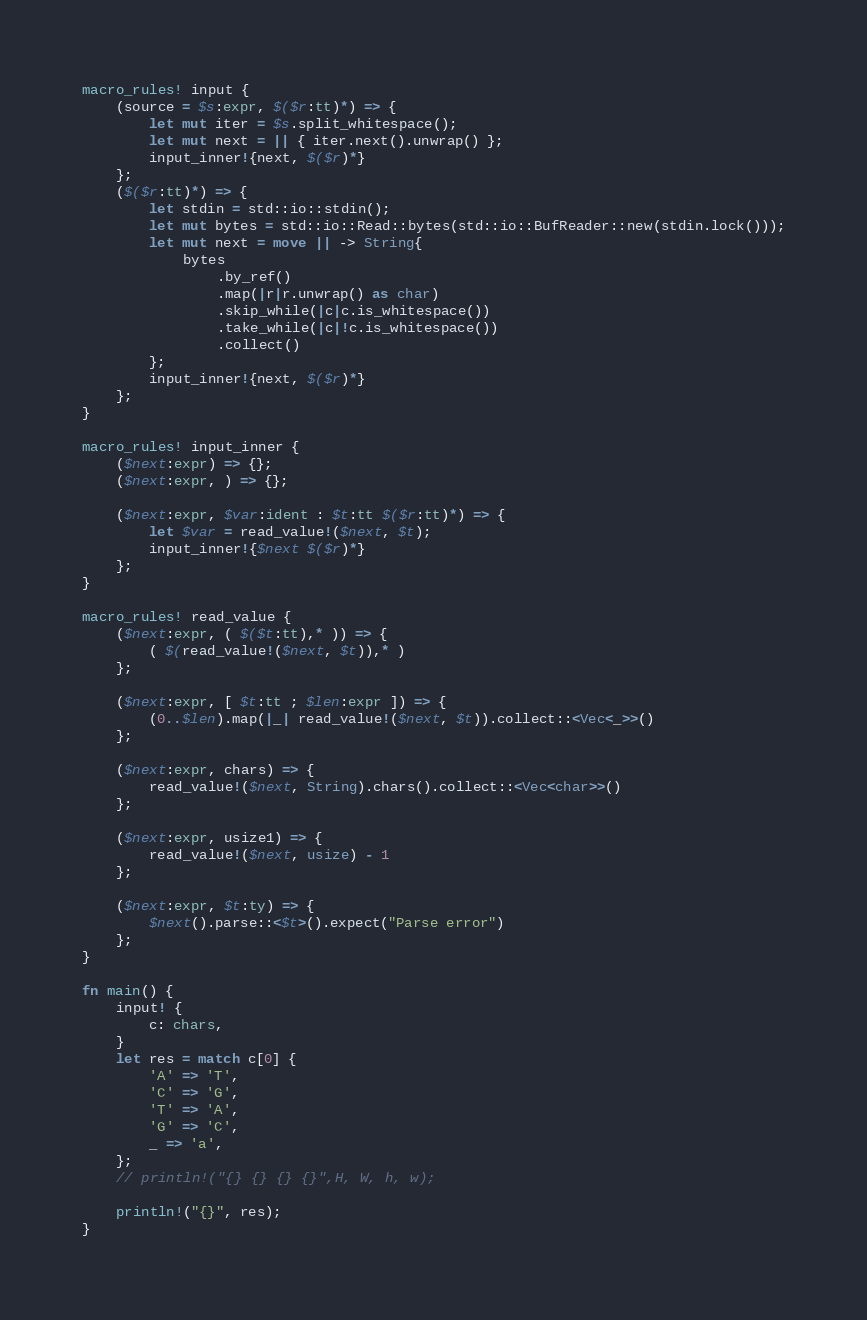Convert code to text. <code><loc_0><loc_0><loc_500><loc_500><_Rust_>macro_rules! input {
    (source = $s:expr, $($r:tt)*) => {
        let mut iter = $s.split_whitespace();
        let mut next = || { iter.next().unwrap() };
        input_inner!{next, $($r)*}
    };
    ($($r:tt)*) => {
        let stdin = std::io::stdin();
        let mut bytes = std::io::Read::bytes(std::io::BufReader::new(stdin.lock()));
        let mut next = move || -> String{
            bytes
                .by_ref()
                .map(|r|r.unwrap() as char)
                .skip_while(|c|c.is_whitespace())
                .take_while(|c|!c.is_whitespace())
                .collect()
        };
        input_inner!{next, $($r)*}
    };
}

macro_rules! input_inner {
    ($next:expr) => {};
    ($next:expr, ) => {};

    ($next:expr, $var:ident : $t:tt $($r:tt)*) => {
        let $var = read_value!($next, $t);
        input_inner!{$next $($r)*}
    };
}

macro_rules! read_value {
    ($next:expr, ( $($t:tt),* )) => {
        ( $(read_value!($next, $t)),* )
    };

    ($next:expr, [ $t:tt ; $len:expr ]) => {
        (0..$len).map(|_| read_value!($next, $t)).collect::<Vec<_>>()
    };

    ($next:expr, chars) => {
        read_value!($next, String).chars().collect::<Vec<char>>()
    };

    ($next:expr, usize1) => {
        read_value!($next, usize) - 1
    };

    ($next:expr, $t:ty) => {
        $next().parse::<$t>().expect("Parse error")
    };
}

fn main() {
    input! {
        c: chars,
    }
    let res = match c[0] {
        'A' => 'T',
        'C' => 'G',
        'T' => 'A',
        'G' => 'C',
        _ => 'a',
    };
    // println!("{} {} {} {}",H, W, h, w);

    println!("{}", res);
}
</code> 